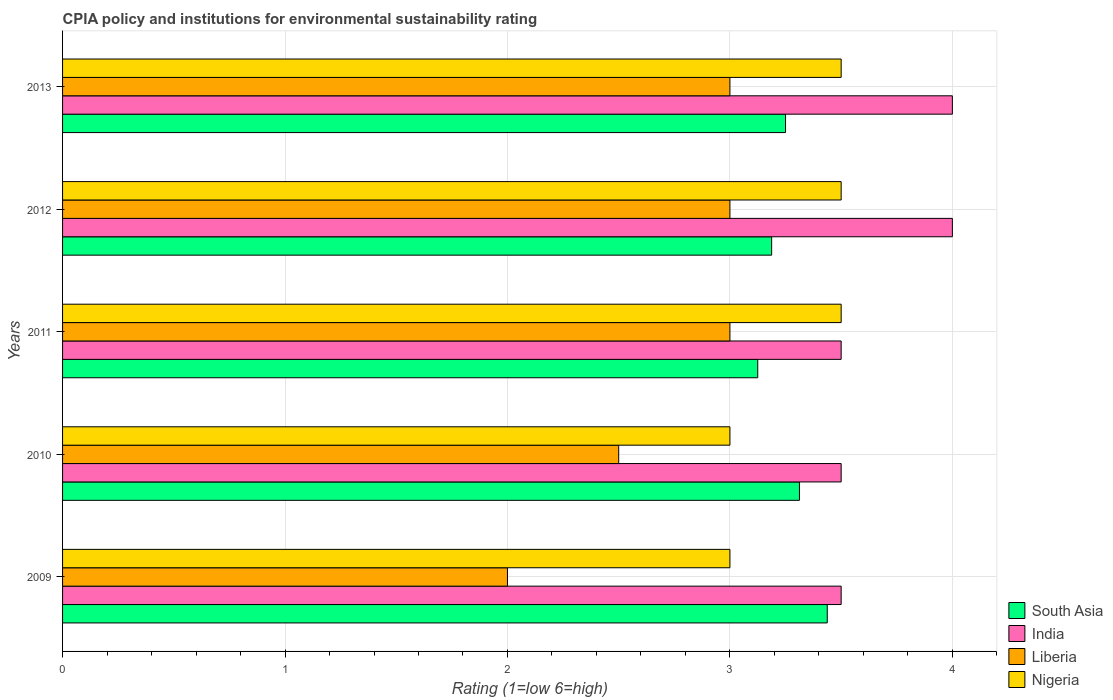How many different coloured bars are there?
Make the answer very short. 4. How many groups of bars are there?
Keep it short and to the point. 5. How many bars are there on the 3rd tick from the bottom?
Give a very brief answer. 4. What is the label of the 2nd group of bars from the top?
Keep it short and to the point. 2012. In how many cases, is the number of bars for a given year not equal to the number of legend labels?
Make the answer very short. 0. What is the CPIA rating in Nigeria in 2010?
Provide a succinct answer. 3. Across all years, what is the maximum CPIA rating in Nigeria?
Offer a terse response. 3.5. Across all years, what is the minimum CPIA rating in South Asia?
Provide a succinct answer. 3.12. In which year was the CPIA rating in India maximum?
Your answer should be very brief. 2012. What is the difference between the CPIA rating in Nigeria in 2011 and that in 2012?
Provide a succinct answer. 0. What is the difference between the CPIA rating in India in 2009 and the CPIA rating in Nigeria in 2013?
Offer a very short reply. 0. What is the average CPIA rating in Nigeria per year?
Offer a terse response. 3.3. In the year 2009, what is the difference between the CPIA rating in Liberia and CPIA rating in India?
Offer a very short reply. -1.5. In how many years, is the CPIA rating in Liberia greater than 2.6 ?
Your answer should be very brief. 3. What is the difference between the highest and the lowest CPIA rating in South Asia?
Offer a very short reply. 0.31. In how many years, is the CPIA rating in South Asia greater than the average CPIA rating in South Asia taken over all years?
Your answer should be very brief. 2. What does the 1st bar from the top in 2013 represents?
Offer a terse response. Nigeria. What does the 4th bar from the bottom in 2010 represents?
Give a very brief answer. Nigeria. Is it the case that in every year, the sum of the CPIA rating in India and CPIA rating in Liberia is greater than the CPIA rating in Nigeria?
Your answer should be very brief. Yes. Are all the bars in the graph horizontal?
Your answer should be very brief. Yes. Are the values on the major ticks of X-axis written in scientific E-notation?
Keep it short and to the point. No. Does the graph contain any zero values?
Your answer should be very brief. No. Does the graph contain grids?
Offer a terse response. Yes. How are the legend labels stacked?
Ensure brevity in your answer.  Vertical. What is the title of the graph?
Offer a very short reply. CPIA policy and institutions for environmental sustainability rating. What is the Rating (1=low 6=high) of South Asia in 2009?
Provide a short and direct response. 3.44. What is the Rating (1=low 6=high) of India in 2009?
Make the answer very short. 3.5. What is the Rating (1=low 6=high) in Liberia in 2009?
Provide a short and direct response. 2. What is the Rating (1=low 6=high) of South Asia in 2010?
Your answer should be compact. 3.31. What is the Rating (1=low 6=high) in India in 2010?
Provide a succinct answer. 3.5. What is the Rating (1=low 6=high) in Liberia in 2010?
Provide a short and direct response. 2.5. What is the Rating (1=low 6=high) of South Asia in 2011?
Give a very brief answer. 3.12. What is the Rating (1=low 6=high) in India in 2011?
Keep it short and to the point. 3.5. What is the Rating (1=low 6=high) in Liberia in 2011?
Offer a very short reply. 3. What is the Rating (1=low 6=high) of Nigeria in 2011?
Ensure brevity in your answer.  3.5. What is the Rating (1=low 6=high) of South Asia in 2012?
Provide a short and direct response. 3.19. What is the Rating (1=low 6=high) of India in 2012?
Make the answer very short. 4. What is the Rating (1=low 6=high) in Nigeria in 2012?
Offer a very short reply. 3.5. What is the Rating (1=low 6=high) of Nigeria in 2013?
Make the answer very short. 3.5. Across all years, what is the maximum Rating (1=low 6=high) in South Asia?
Your answer should be very brief. 3.44. Across all years, what is the maximum Rating (1=low 6=high) of Liberia?
Ensure brevity in your answer.  3. Across all years, what is the minimum Rating (1=low 6=high) in South Asia?
Make the answer very short. 3.12. Across all years, what is the minimum Rating (1=low 6=high) in India?
Make the answer very short. 3.5. Across all years, what is the minimum Rating (1=low 6=high) in Nigeria?
Your answer should be compact. 3. What is the total Rating (1=low 6=high) in South Asia in the graph?
Keep it short and to the point. 16.31. What is the total Rating (1=low 6=high) of Liberia in the graph?
Your response must be concise. 13.5. What is the difference between the Rating (1=low 6=high) in South Asia in 2009 and that in 2010?
Offer a very short reply. 0.12. What is the difference between the Rating (1=low 6=high) in Nigeria in 2009 and that in 2010?
Provide a short and direct response. 0. What is the difference between the Rating (1=low 6=high) in South Asia in 2009 and that in 2011?
Your answer should be very brief. 0.31. What is the difference between the Rating (1=low 6=high) in India in 2009 and that in 2011?
Your response must be concise. 0. What is the difference between the Rating (1=low 6=high) of Nigeria in 2009 and that in 2011?
Give a very brief answer. -0.5. What is the difference between the Rating (1=low 6=high) in Liberia in 2009 and that in 2012?
Your answer should be compact. -1. What is the difference between the Rating (1=low 6=high) of South Asia in 2009 and that in 2013?
Give a very brief answer. 0.19. What is the difference between the Rating (1=low 6=high) in Liberia in 2009 and that in 2013?
Keep it short and to the point. -1. What is the difference between the Rating (1=low 6=high) of Nigeria in 2009 and that in 2013?
Provide a succinct answer. -0.5. What is the difference between the Rating (1=low 6=high) of South Asia in 2010 and that in 2011?
Make the answer very short. 0.19. What is the difference between the Rating (1=low 6=high) in South Asia in 2010 and that in 2012?
Your response must be concise. 0.12. What is the difference between the Rating (1=low 6=high) in Liberia in 2010 and that in 2012?
Give a very brief answer. -0.5. What is the difference between the Rating (1=low 6=high) in Nigeria in 2010 and that in 2012?
Provide a succinct answer. -0.5. What is the difference between the Rating (1=low 6=high) in South Asia in 2010 and that in 2013?
Provide a succinct answer. 0.06. What is the difference between the Rating (1=low 6=high) of India in 2010 and that in 2013?
Give a very brief answer. -0.5. What is the difference between the Rating (1=low 6=high) of South Asia in 2011 and that in 2012?
Provide a succinct answer. -0.06. What is the difference between the Rating (1=low 6=high) of India in 2011 and that in 2012?
Your response must be concise. -0.5. What is the difference between the Rating (1=low 6=high) of South Asia in 2011 and that in 2013?
Give a very brief answer. -0.12. What is the difference between the Rating (1=low 6=high) of South Asia in 2012 and that in 2013?
Offer a terse response. -0.06. What is the difference between the Rating (1=low 6=high) of Nigeria in 2012 and that in 2013?
Ensure brevity in your answer.  0. What is the difference between the Rating (1=low 6=high) in South Asia in 2009 and the Rating (1=low 6=high) in India in 2010?
Offer a very short reply. -0.06. What is the difference between the Rating (1=low 6=high) of South Asia in 2009 and the Rating (1=low 6=high) of Liberia in 2010?
Provide a short and direct response. 0.94. What is the difference between the Rating (1=low 6=high) in South Asia in 2009 and the Rating (1=low 6=high) in Nigeria in 2010?
Your answer should be very brief. 0.44. What is the difference between the Rating (1=low 6=high) in India in 2009 and the Rating (1=low 6=high) in Liberia in 2010?
Provide a short and direct response. 1. What is the difference between the Rating (1=low 6=high) in India in 2009 and the Rating (1=low 6=high) in Nigeria in 2010?
Provide a short and direct response. 0.5. What is the difference between the Rating (1=low 6=high) in South Asia in 2009 and the Rating (1=low 6=high) in India in 2011?
Your answer should be very brief. -0.06. What is the difference between the Rating (1=low 6=high) in South Asia in 2009 and the Rating (1=low 6=high) in Liberia in 2011?
Keep it short and to the point. 0.44. What is the difference between the Rating (1=low 6=high) of South Asia in 2009 and the Rating (1=low 6=high) of Nigeria in 2011?
Your answer should be compact. -0.06. What is the difference between the Rating (1=low 6=high) in Liberia in 2009 and the Rating (1=low 6=high) in Nigeria in 2011?
Your answer should be very brief. -1.5. What is the difference between the Rating (1=low 6=high) of South Asia in 2009 and the Rating (1=low 6=high) of India in 2012?
Provide a short and direct response. -0.56. What is the difference between the Rating (1=low 6=high) in South Asia in 2009 and the Rating (1=low 6=high) in Liberia in 2012?
Give a very brief answer. 0.44. What is the difference between the Rating (1=low 6=high) of South Asia in 2009 and the Rating (1=low 6=high) of Nigeria in 2012?
Give a very brief answer. -0.06. What is the difference between the Rating (1=low 6=high) in India in 2009 and the Rating (1=low 6=high) in Liberia in 2012?
Provide a succinct answer. 0.5. What is the difference between the Rating (1=low 6=high) of Liberia in 2009 and the Rating (1=low 6=high) of Nigeria in 2012?
Give a very brief answer. -1.5. What is the difference between the Rating (1=low 6=high) of South Asia in 2009 and the Rating (1=low 6=high) of India in 2013?
Ensure brevity in your answer.  -0.56. What is the difference between the Rating (1=low 6=high) in South Asia in 2009 and the Rating (1=low 6=high) in Liberia in 2013?
Offer a very short reply. 0.44. What is the difference between the Rating (1=low 6=high) in South Asia in 2009 and the Rating (1=low 6=high) in Nigeria in 2013?
Keep it short and to the point. -0.06. What is the difference between the Rating (1=low 6=high) in India in 2009 and the Rating (1=low 6=high) in Nigeria in 2013?
Give a very brief answer. 0. What is the difference between the Rating (1=low 6=high) of Liberia in 2009 and the Rating (1=low 6=high) of Nigeria in 2013?
Offer a terse response. -1.5. What is the difference between the Rating (1=low 6=high) of South Asia in 2010 and the Rating (1=low 6=high) of India in 2011?
Make the answer very short. -0.19. What is the difference between the Rating (1=low 6=high) of South Asia in 2010 and the Rating (1=low 6=high) of Liberia in 2011?
Offer a terse response. 0.31. What is the difference between the Rating (1=low 6=high) in South Asia in 2010 and the Rating (1=low 6=high) in Nigeria in 2011?
Your answer should be compact. -0.19. What is the difference between the Rating (1=low 6=high) in India in 2010 and the Rating (1=low 6=high) in Nigeria in 2011?
Keep it short and to the point. 0. What is the difference between the Rating (1=low 6=high) of South Asia in 2010 and the Rating (1=low 6=high) of India in 2012?
Keep it short and to the point. -0.69. What is the difference between the Rating (1=low 6=high) in South Asia in 2010 and the Rating (1=low 6=high) in Liberia in 2012?
Provide a short and direct response. 0.31. What is the difference between the Rating (1=low 6=high) of South Asia in 2010 and the Rating (1=low 6=high) of Nigeria in 2012?
Your response must be concise. -0.19. What is the difference between the Rating (1=low 6=high) in India in 2010 and the Rating (1=low 6=high) in Nigeria in 2012?
Offer a very short reply. 0. What is the difference between the Rating (1=low 6=high) in South Asia in 2010 and the Rating (1=low 6=high) in India in 2013?
Your response must be concise. -0.69. What is the difference between the Rating (1=low 6=high) of South Asia in 2010 and the Rating (1=low 6=high) of Liberia in 2013?
Keep it short and to the point. 0.31. What is the difference between the Rating (1=low 6=high) in South Asia in 2010 and the Rating (1=low 6=high) in Nigeria in 2013?
Your answer should be compact. -0.19. What is the difference between the Rating (1=low 6=high) in India in 2010 and the Rating (1=low 6=high) in Liberia in 2013?
Give a very brief answer. 0.5. What is the difference between the Rating (1=low 6=high) in India in 2010 and the Rating (1=low 6=high) in Nigeria in 2013?
Your answer should be compact. 0. What is the difference between the Rating (1=low 6=high) of South Asia in 2011 and the Rating (1=low 6=high) of India in 2012?
Your answer should be compact. -0.88. What is the difference between the Rating (1=low 6=high) of South Asia in 2011 and the Rating (1=low 6=high) of Liberia in 2012?
Your answer should be very brief. 0.12. What is the difference between the Rating (1=low 6=high) of South Asia in 2011 and the Rating (1=low 6=high) of Nigeria in 2012?
Your answer should be compact. -0.38. What is the difference between the Rating (1=low 6=high) in Liberia in 2011 and the Rating (1=low 6=high) in Nigeria in 2012?
Your response must be concise. -0.5. What is the difference between the Rating (1=low 6=high) of South Asia in 2011 and the Rating (1=low 6=high) of India in 2013?
Keep it short and to the point. -0.88. What is the difference between the Rating (1=low 6=high) in South Asia in 2011 and the Rating (1=low 6=high) in Liberia in 2013?
Make the answer very short. 0.12. What is the difference between the Rating (1=low 6=high) in South Asia in 2011 and the Rating (1=low 6=high) in Nigeria in 2013?
Make the answer very short. -0.38. What is the difference between the Rating (1=low 6=high) of South Asia in 2012 and the Rating (1=low 6=high) of India in 2013?
Give a very brief answer. -0.81. What is the difference between the Rating (1=low 6=high) in South Asia in 2012 and the Rating (1=low 6=high) in Liberia in 2013?
Provide a succinct answer. 0.19. What is the difference between the Rating (1=low 6=high) of South Asia in 2012 and the Rating (1=low 6=high) of Nigeria in 2013?
Make the answer very short. -0.31. What is the difference between the Rating (1=low 6=high) of India in 2012 and the Rating (1=low 6=high) of Nigeria in 2013?
Your answer should be compact. 0.5. What is the difference between the Rating (1=low 6=high) in Liberia in 2012 and the Rating (1=low 6=high) in Nigeria in 2013?
Make the answer very short. -0.5. What is the average Rating (1=low 6=high) of South Asia per year?
Make the answer very short. 3.26. What is the average Rating (1=low 6=high) of India per year?
Ensure brevity in your answer.  3.7. What is the average Rating (1=low 6=high) of Liberia per year?
Provide a short and direct response. 2.7. In the year 2009, what is the difference between the Rating (1=low 6=high) in South Asia and Rating (1=low 6=high) in India?
Provide a short and direct response. -0.06. In the year 2009, what is the difference between the Rating (1=low 6=high) of South Asia and Rating (1=low 6=high) of Liberia?
Offer a very short reply. 1.44. In the year 2009, what is the difference between the Rating (1=low 6=high) in South Asia and Rating (1=low 6=high) in Nigeria?
Provide a succinct answer. 0.44. In the year 2009, what is the difference between the Rating (1=low 6=high) in Liberia and Rating (1=low 6=high) in Nigeria?
Your answer should be very brief. -1. In the year 2010, what is the difference between the Rating (1=low 6=high) in South Asia and Rating (1=low 6=high) in India?
Offer a very short reply. -0.19. In the year 2010, what is the difference between the Rating (1=low 6=high) of South Asia and Rating (1=low 6=high) of Liberia?
Keep it short and to the point. 0.81. In the year 2010, what is the difference between the Rating (1=low 6=high) in South Asia and Rating (1=low 6=high) in Nigeria?
Offer a very short reply. 0.31. In the year 2010, what is the difference between the Rating (1=low 6=high) of India and Rating (1=low 6=high) of Liberia?
Offer a very short reply. 1. In the year 2011, what is the difference between the Rating (1=low 6=high) of South Asia and Rating (1=low 6=high) of India?
Offer a terse response. -0.38. In the year 2011, what is the difference between the Rating (1=low 6=high) of South Asia and Rating (1=low 6=high) of Liberia?
Make the answer very short. 0.12. In the year 2011, what is the difference between the Rating (1=low 6=high) of South Asia and Rating (1=low 6=high) of Nigeria?
Your answer should be compact. -0.38. In the year 2011, what is the difference between the Rating (1=low 6=high) of Liberia and Rating (1=low 6=high) of Nigeria?
Ensure brevity in your answer.  -0.5. In the year 2012, what is the difference between the Rating (1=low 6=high) in South Asia and Rating (1=low 6=high) in India?
Provide a short and direct response. -0.81. In the year 2012, what is the difference between the Rating (1=low 6=high) of South Asia and Rating (1=low 6=high) of Liberia?
Make the answer very short. 0.19. In the year 2012, what is the difference between the Rating (1=low 6=high) of South Asia and Rating (1=low 6=high) of Nigeria?
Ensure brevity in your answer.  -0.31. In the year 2012, what is the difference between the Rating (1=low 6=high) of India and Rating (1=low 6=high) of Liberia?
Provide a succinct answer. 1. In the year 2012, what is the difference between the Rating (1=low 6=high) in Liberia and Rating (1=low 6=high) in Nigeria?
Your answer should be very brief. -0.5. In the year 2013, what is the difference between the Rating (1=low 6=high) in South Asia and Rating (1=low 6=high) in India?
Your answer should be compact. -0.75. In the year 2013, what is the difference between the Rating (1=low 6=high) in South Asia and Rating (1=low 6=high) in Liberia?
Ensure brevity in your answer.  0.25. In the year 2013, what is the difference between the Rating (1=low 6=high) in Liberia and Rating (1=low 6=high) in Nigeria?
Offer a terse response. -0.5. What is the ratio of the Rating (1=low 6=high) in South Asia in 2009 to that in 2010?
Ensure brevity in your answer.  1.04. What is the ratio of the Rating (1=low 6=high) in India in 2009 to that in 2010?
Offer a terse response. 1. What is the ratio of the Rating (1=low 6=high) in Liberia in 2009 to that in 2010?
Provide a short and direct response. 0.8. What is the ratio of the Rating (1=low 6=high) in Nigeria in 2009 to that in 2011?
Offer a very short reply. 0.86. What is the ratio of the Rating (1=low 6=high) of South Asia in 2009 to that in 2012?
Provide a succinct answer. 1.08. What is the ratio of the Rating (1=low 6=high) of India in 2009 to that in 2012?
Make the answer very short. 0.88. What is the ratio of the Rating (1=low 6=high) of South Asia in 2009 to that in 2013?
Make the answer very short. 1.06. What is the ratio of the Rating (1=low 6=high) of Liberia in 2009 to that in 2013?
Ensure brevity in your answer.  0.67. What is the ratio of the Rating (1=low 6=high) in South Asia in 2010 to that in 2011?
Offer a terse response. 1.06. What is the ratio of the Rating (1=low 6=high) of South Asia in 2010 to that in 2012?
Your response must be concise. 1.04. What is the ratio of the Rating (1=low 6=high) in India in 2010 to that in 2012?
Provide a succinct answer. 0.88. What is the ratio of the Rating (1=low 6=high) of Liberia in 2010 to that in 2012?
Provide a short and direct response. 0.83. What is the ratio of the Rating (1=low 6=high) in Nigeria in 2010 to that in 2012?
Provide a succinct answer. 0.86. What is the ratio of the Rating (1=low 6=high) of South Asia in 2010 to that in 2013?
Offer a terse response. 1.02. What is the ratio of the Rating (1=low 6=high) in South Asia in 2011 to that in 2012?
Keep it short and to the point. 0.98. What is the ratio of the Rating (1=low 6=high) in India in 2011 to that in 2012?
Give a very brief answer. 0.88. What is the ratio of the Rating (1=low 6=high) in Liberia in 2011 to that in 2012?
Your answer should be compact. 1. What is the ratio of the Rating (1=low 6=high) in Nigeria in 2011 to that in 2012?
Your response must be concise. 1. What is the ratio of the Rating (1=low 6=high) of South Asia in 2011 to that in 2013?
Ensure brevity in your answer.  0.96. What is the ratio of the Rating (1=low 6=high) of India in 2011 to that in 2013?
Provide a short and direct response. 0.88. What is the ratio of the Rating (1=low 6=high) in South Asia in 2012 to that in 2013?
Your answer should be compact. 0.98. What is the ratio of the Rating (1=low 6=high) in India in 2012 to that in 2013?
Give a very brief answer. 1. What is the ratio of the Rating (1=low 6=high) in Liberia in 2012 to that in 2013?
Your response must be concise. 1. What is the difference between the highest and the second highest Rating (1=low 6=high) of South Asia?
Your answer should be very brief. 0.12. What is the difference between the highest and the second highest Rating (1=low 6=high) in India?
Offer a terse response. 0. What is the difference between the highest and the second highest Rating (1=low 6=high) of Liberia?
Make the answer very short. 0. What is the difference between the highest and the second highest Rating (1=low 6=high) in Nigeria?
Provide a succinct answer. 0. What is the difference between the highest and the lowest Rating (1=low 6=high) of South Asia?
Give a very brief answer. 0.31. What is the difference between the highest and the lowest Rating (1=low 6=high) of Liberia?
Keep it short and to the point. 1. What is the difference between the highest and the lowest Rating (1=low 6=high) of Nigeria?
Make the answer very short. 0.5. 